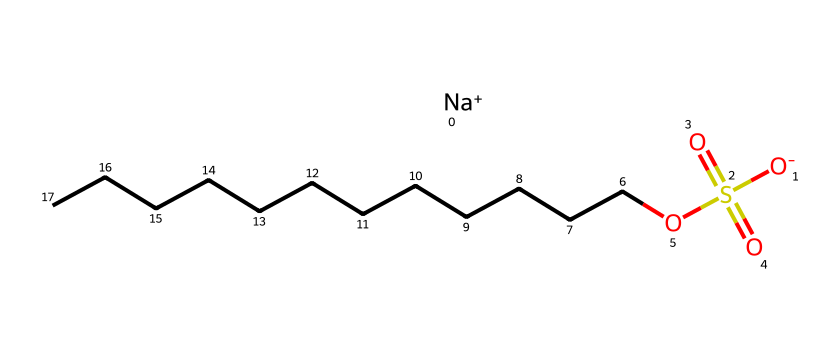What is the total number of carbon atoms in sodium dodecyl sulfate? The chemical structure contains a long alkyl chain represented by CCCCCCCCCCCC, indicating there are 12 carbon atoms in total.
Answer: 12 What functional groups are present in sodium dodecyl sulfate? The structure shows a sulfate group (S(=O)(=O)O) along with a sodium ion ([Na+]) and a long hydrocarbon chain. Thus, the groups identified are sulfate and alkyl.
Answer: sulfate, alkyl How many oxygen atoms are in sodium dodecyl sulfate? The sulfate group contains four oxygen atoms (from S(=O)(=O)O), and there are no additional oxygen atoms in the hydrocarbon chain, leading to a total of four.
Answer: 4 What type of surfactant is sodium dodecyl sulfate? Sodium dodecyl sulfate is an anionic surfactant, as indicated by the presence of a negatively charged sulfate group and a sodium counterion.
Answer: anionic Which part of the structure contributes to its surfactant properties? The hydrophilic part of sodium dodecyl sulfate is the sulfate group, which allows it to interact with water, while the long hydrocarbon chain (hydrophobic) interacts with oils, giving it surfactant properties.
Answer: sulfate group What is the significance of the sodium ion in this chemical? The sodium ion acts as a counterion to balance the negative charge of the sulfate group, contributing to the solubility and stability of the compound in aqueous solutions.
Answer: counterion 